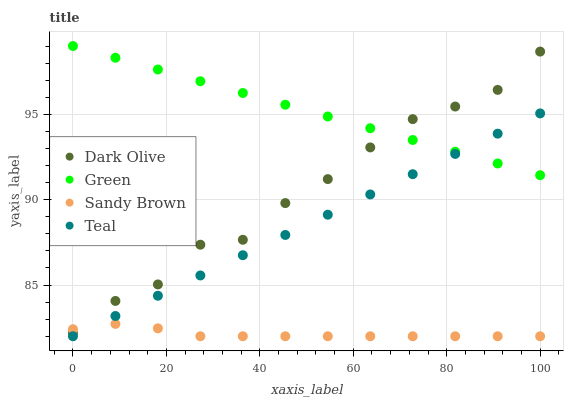Does Sandy Brown have the minimum area under the curve?
Answer yes or no. Yes. Does Green have the maximum area under the curve?
Answer yes or no. Yes. Does Dark Olive have the minimum area under the curve?
Answer yes or no. No. Does Dark Olive have the maximum area under the curve?
Answer yes or no. No. Is Teal the smoothest?
Answer yes or no. Yes. Is Dark Olive the roughest?
Answer yes or no. Yes. Is Green the smoothest?
Answer yes or no. No. Is Green the roughest?
Answer yes or no. No. Does Sandy Brown have the lowest value?
Answer yes or no. Yes. Does Dark Olive have the lowest value?
Answer yes or no. No. Does Green have the highest value?
Answer yes or no. Yes. Does Dark Olive have the highest value?
Answer yes or no. No. Is Teal less than Dark Olive?
Answer yes or no. Yes. Is Dark Olive greater than Teal?
Answer yes or no. Yes. Does Dark Olive intersect Sandy Brown?
Answer yes or no. Yes. Is Dark Olive less than Sandy Brown?
Answer yes or no. No. Is Dark Olive greater than Sandy Brown?
Answer yes or no. No. Does Teal intersect Dark Olive?
Answer yes or no. No. 